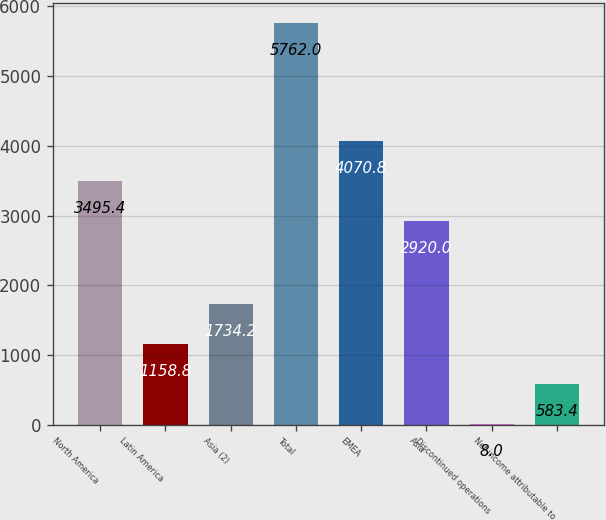Convert chart. <chart><loc_0><loc_0><loc_500><loc_500><bar_chart><fcel>North America<fcel>Latin America<fcel>Asia (2)<fcel>Total<fcel>EMEA<fcel>Asia<fcel>Discontinued operations<fcel>Net income attributable to<nl><fcel>3495.4<fcel>1158.8<fcel>1734.2<fcel>5762<fcel>4070.8<fcel>2920<fcel>8<fcel>583.4<nl></chart> 